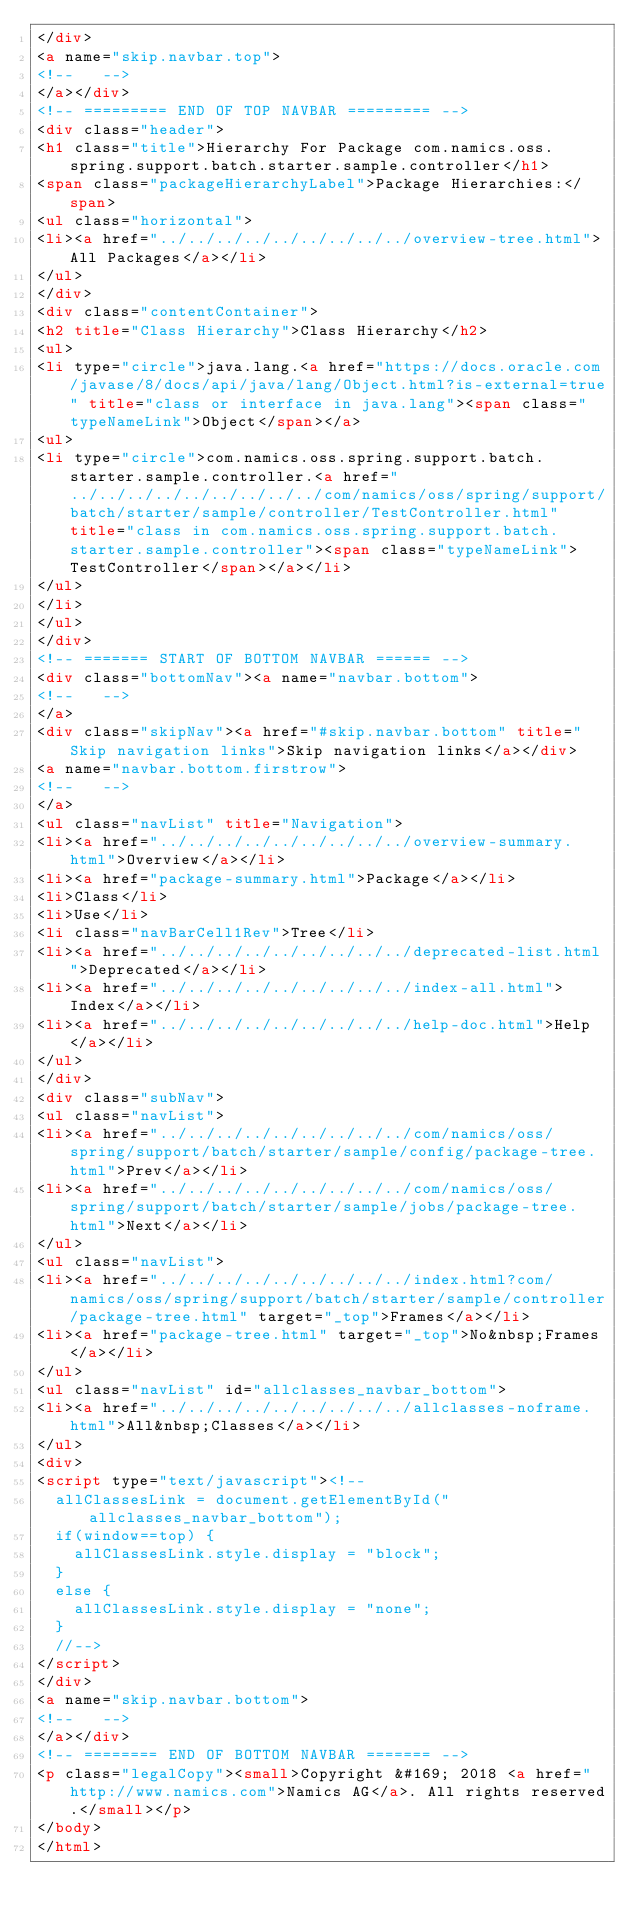<code> <loc_0><loc_0><loc_500><loc_500><_HTML_></div>
<a name="skip.navbar.top">
<!--   -->
</a></div>
<!-- ========= END OF TOP NAVBAR ========= -->
<div class="header">
<h1 class="title">Hierarchy For Package com.namics.oss.spring.support.batch.starter.sample.controller</h1>
<span class="packageHierarchyLabel">Package Hierarchies:</span>
<ul class="horizontal">
<li><a href="../../../../../../../../../overview-tree.html">All Packages</a></li>
</ul>
</div>
<div class="contentContainer">
<h2 title="Class Hierarchy">Class Hierarchy</h2>
<ul>
<li type="circle">java.lang.<a href="https://docs.oracle.com/javase/8/docs/api/java/lang/Object.html?is-external=true" title="class or interface in java.lang"><span class="typeNameLink">Object</span></a>
<ul>
<li type="circle">com.namics.oss.spring.support.batch.starter.sample.controller.<a href="../../../../../../../../../com/namics/oss/spring/support/batch/starter/sample/controller/TestController.html" title="class in com.namics.oss.spring.support.batch.starter.sample.controller"><span class="typeNameLink">TestController</span></a></li>
</ul>
</li>
</ul>
</div>
<!-- ======= START OF BOTTOM NAVBAR ====== -->
<div class="bottomNav"><a name="navbar.bottom">
<!--   -->
</a>
<div class="skipNav"><a href="#skip.navbar.bottom" title="Skip navigation links">Skip navigation links</a></div>
<a name="navbar.bottom.firstrow">
<!--   -->
</a>
<ul class="navList" title="Navigation">
<li><a href="../../../../../../../../../overview-summary.html">Overview</a></li>
<li><a href="package-summary.html">Package</a></li>
<li>Class</li>
<li>Use</li>
<li class="navBarCell1Rev">Tree</li>
<li><a href="../../../../../../../../../deprecated-list.html">Deprecated</a></li>
<li><a href="../../../../../../../../../index-all.html">Index</a></li>
<li><a href="../../../../../../../../../help-doc.html">Help</a></li>
</ul>
</div>
<div class="subNav">
<ul class="navList">
<li><a href="../../../../../../../../../com/namics/oss/spring/support/batch/starter/sample/config/package-tree.html">Prev</a></li>
<li><a href="../../../../../../../../../com/namics/oss/spring/support/batch/starter/sample/jobs/package-tree.html">Next</a></li>
</ul>
<ul class="navList">
<li><a href="../../../../../../../../../index.html?com/namics/oss/spring/support/batch/starter/sample/controller/package-tree.html" target="_top">Frames</a></li>
<li><a href="package-tree.html" target="_top">No&nbsp;Frames</a></li>
</ul>
<ul class="navList" id="allclasses_navbar_bottom">
<li><a href="../../../../../../../../../allclasses-noframe.html">All&nbsp;Classes</a></li>
</ul>
<div>
<script type="text/javascript"><!--
  allClassesLink = document.getElementById("allclasses_navbar_bottom");
  if(window==top) {
    allClassesLink.style.display = "block";
  }
  else {
    allClassesLink.style.display = "none";
  }
  //-->
</script>
</div>
<a name="skip.navbar.bottom">
<!--   -->
</a></div>
<!-- ======== END OF BOTTOM NAVBAR ======= -->
<p class="legalCopy"><small>Copyright &#169; 2018 <a href="http://www.namics.com">Namics AG</a>. All rights reserved.</small></p>
</body>
</html>
</code> 